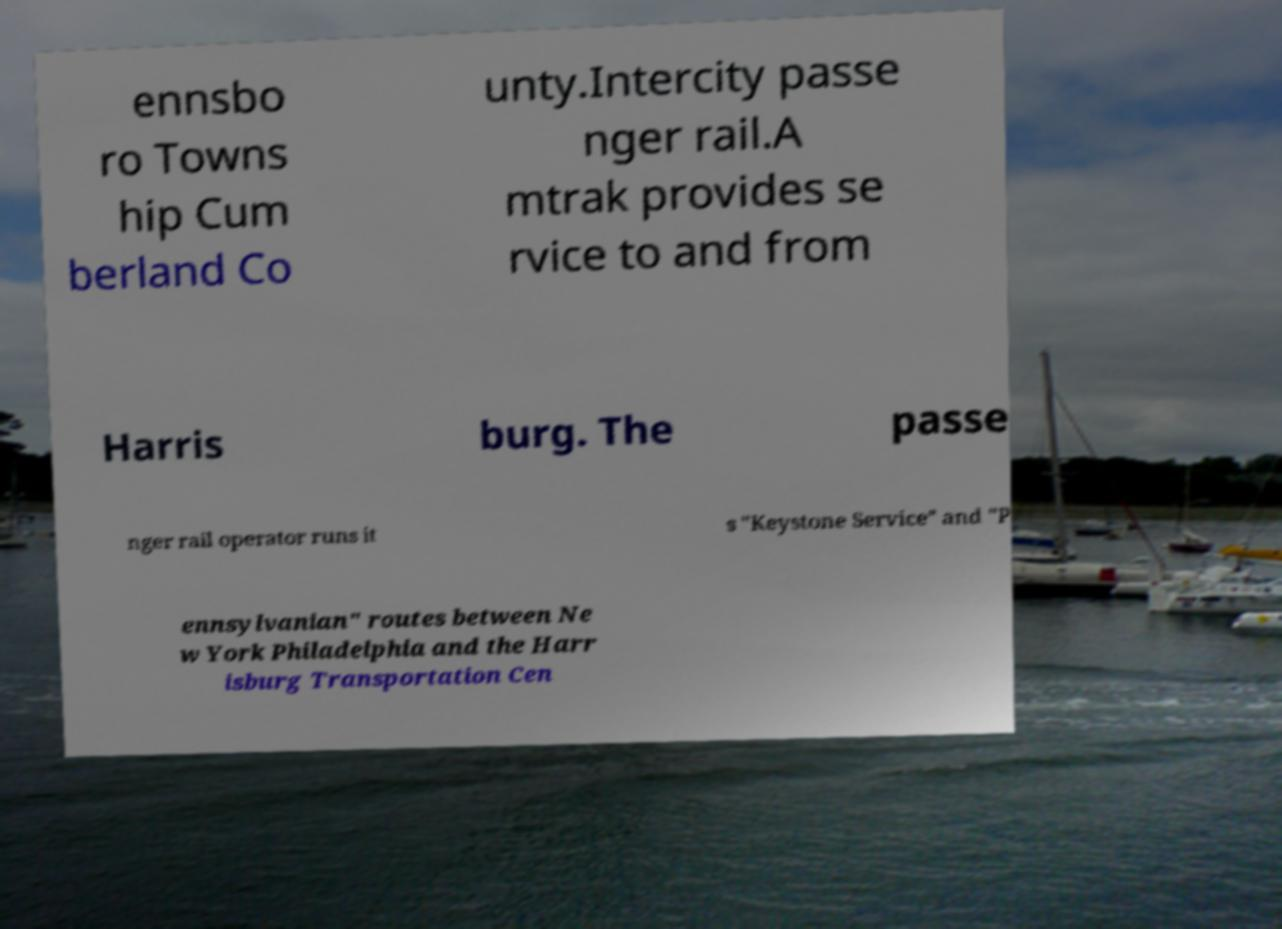There's text embedded in this image that I need extracted. Can you transcribe it verbatim? ennsbo ro Towns hip Cum berland Co unty.Intercity passe nger rail.A mtrak provides se rvice to and from Harris burg. The passe nger rail operator runs it s "Keystone Service" and "P ennsylvanian" routes between Ne w York Philadelphia and the Harr isburg Transportation Cen 